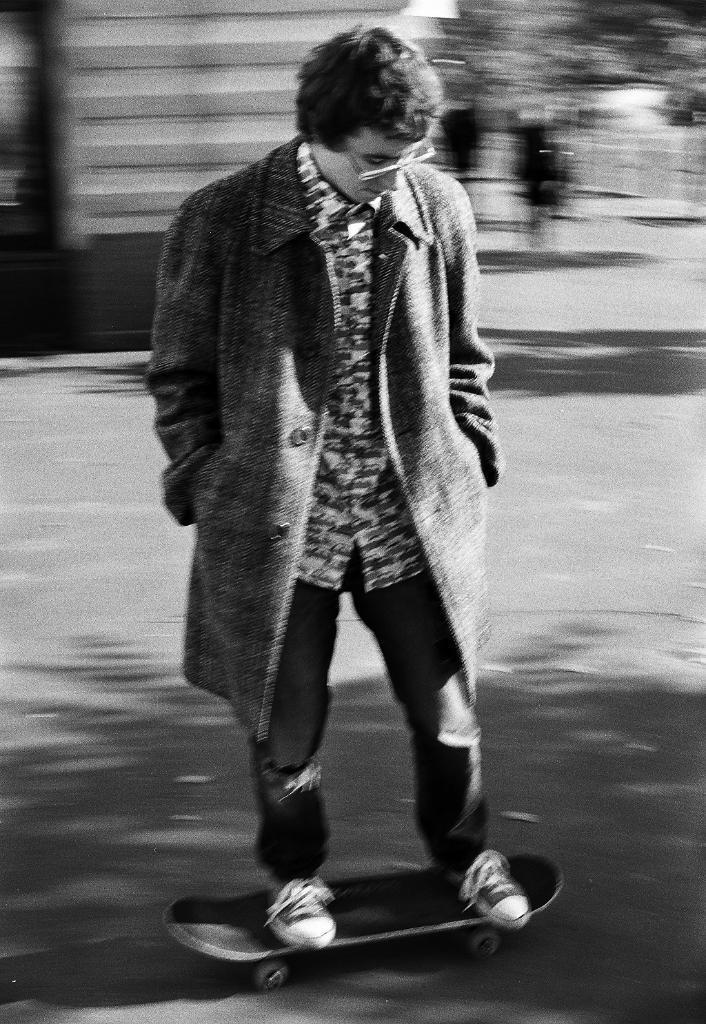In one or two sentences, can you explain what this image depicts? In this image I see a man over here who is on this skateboard and I see that it is totally blurred in the background and I see that this is a black and white image. 